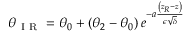<formula> <loc_0><loc_0><loc_500><loc_500>\theta _ { I R } = \theta _ { 0 } + \left ( \theta _ { 2 } - \theta _ { 0 } \right ) e ^ { - a \frac { \left ( z _ { R } - z \right ) } { \epsilon \sqrt { \delta } } }</formula> 